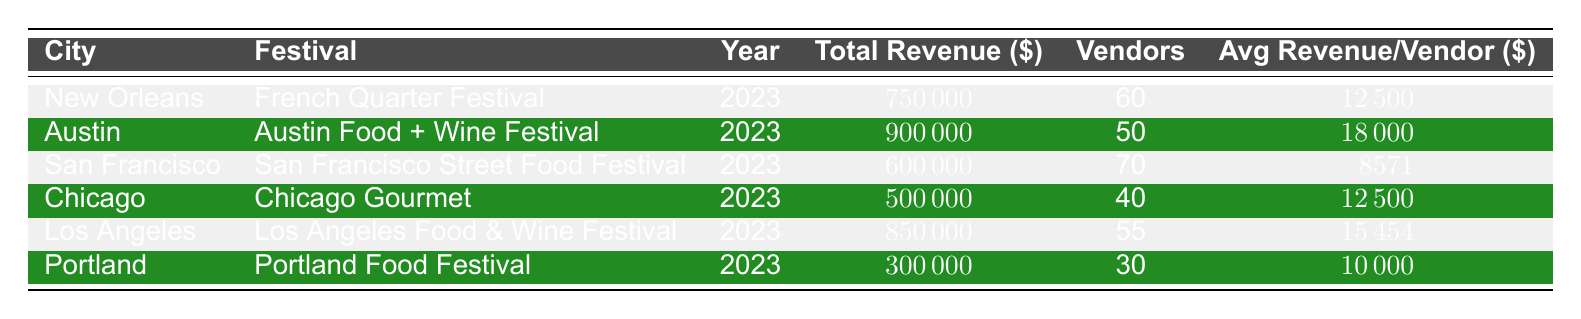What city had the highest total revenue from food vendors? By reviewing the total revenue column, we see that Austin had a total revenue of 900,000, which is higher than any other city listed.
Answer: Austin What is the average revenue per vendor for the Chicago Gourmet festival? The table shows that the average revenue per vendor for Chicago Gourmet is 12,500.
Answer: 12500 How many vendors participated in the San Francisco Street Food Festival? The data indicates that 70 vendors participated in the San Francisco Street Food Festival as stated in the vendor column for that festival.
Answer: 70 Which city had the lowest total revenue among the festivals listed? Comparing the total revenue for all cities, Portland has the lowest total revenue of 300,000, as listed in the table.
Answer: Portland What is the average total revenue across all festivals listed? To find the average, we sum the total revenues: (750000 + 900000 + 600000 + 500000 + 850000 + 300000 = 4000000). There are 6 entries, so the average is 4000000 / 6 = 666667.
Answer: 666667 Is the average revenue per vendor higher in Los Angeles than in New Orleans? In Los Angeles, the average revenue per vendor is 15,454, while in New Orleans, it's 12,500. Since 15,454 is greater than 12,500, the statement is true.
Answer: Yes What is the total number of vendors across all festivals? To find the total number of vendors, we add the number of vendors for each festival: (60 + 50 + 70 + 40 + 55 + 30 = 305).
Answer: 305 Which festival had a total revenue closer to 500,000, Chicago Gourmet or San Francisco Street Food Festival? Chicago Gourmet had a total revenue of 500,000 which is equal to 500,000 while San Francisco Street Food Festival had 600,000. Hence, Chicago Gourmet is closer.
Answer: Chicago Gourmet Is the average revenue per vendor for the Portland Food Festival greater than 10,000? The average revenue per vendor for the Portland Food Festival is listed as 10,000, which is not greater than 10,000. Therefore, the statement is false.
Answer: No 